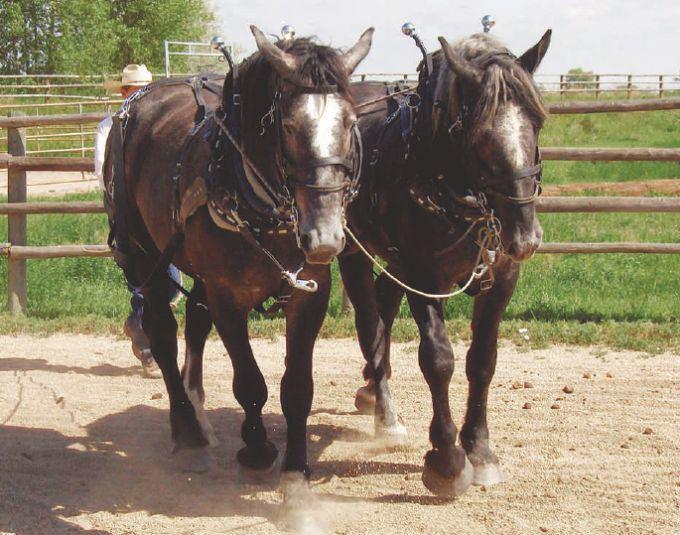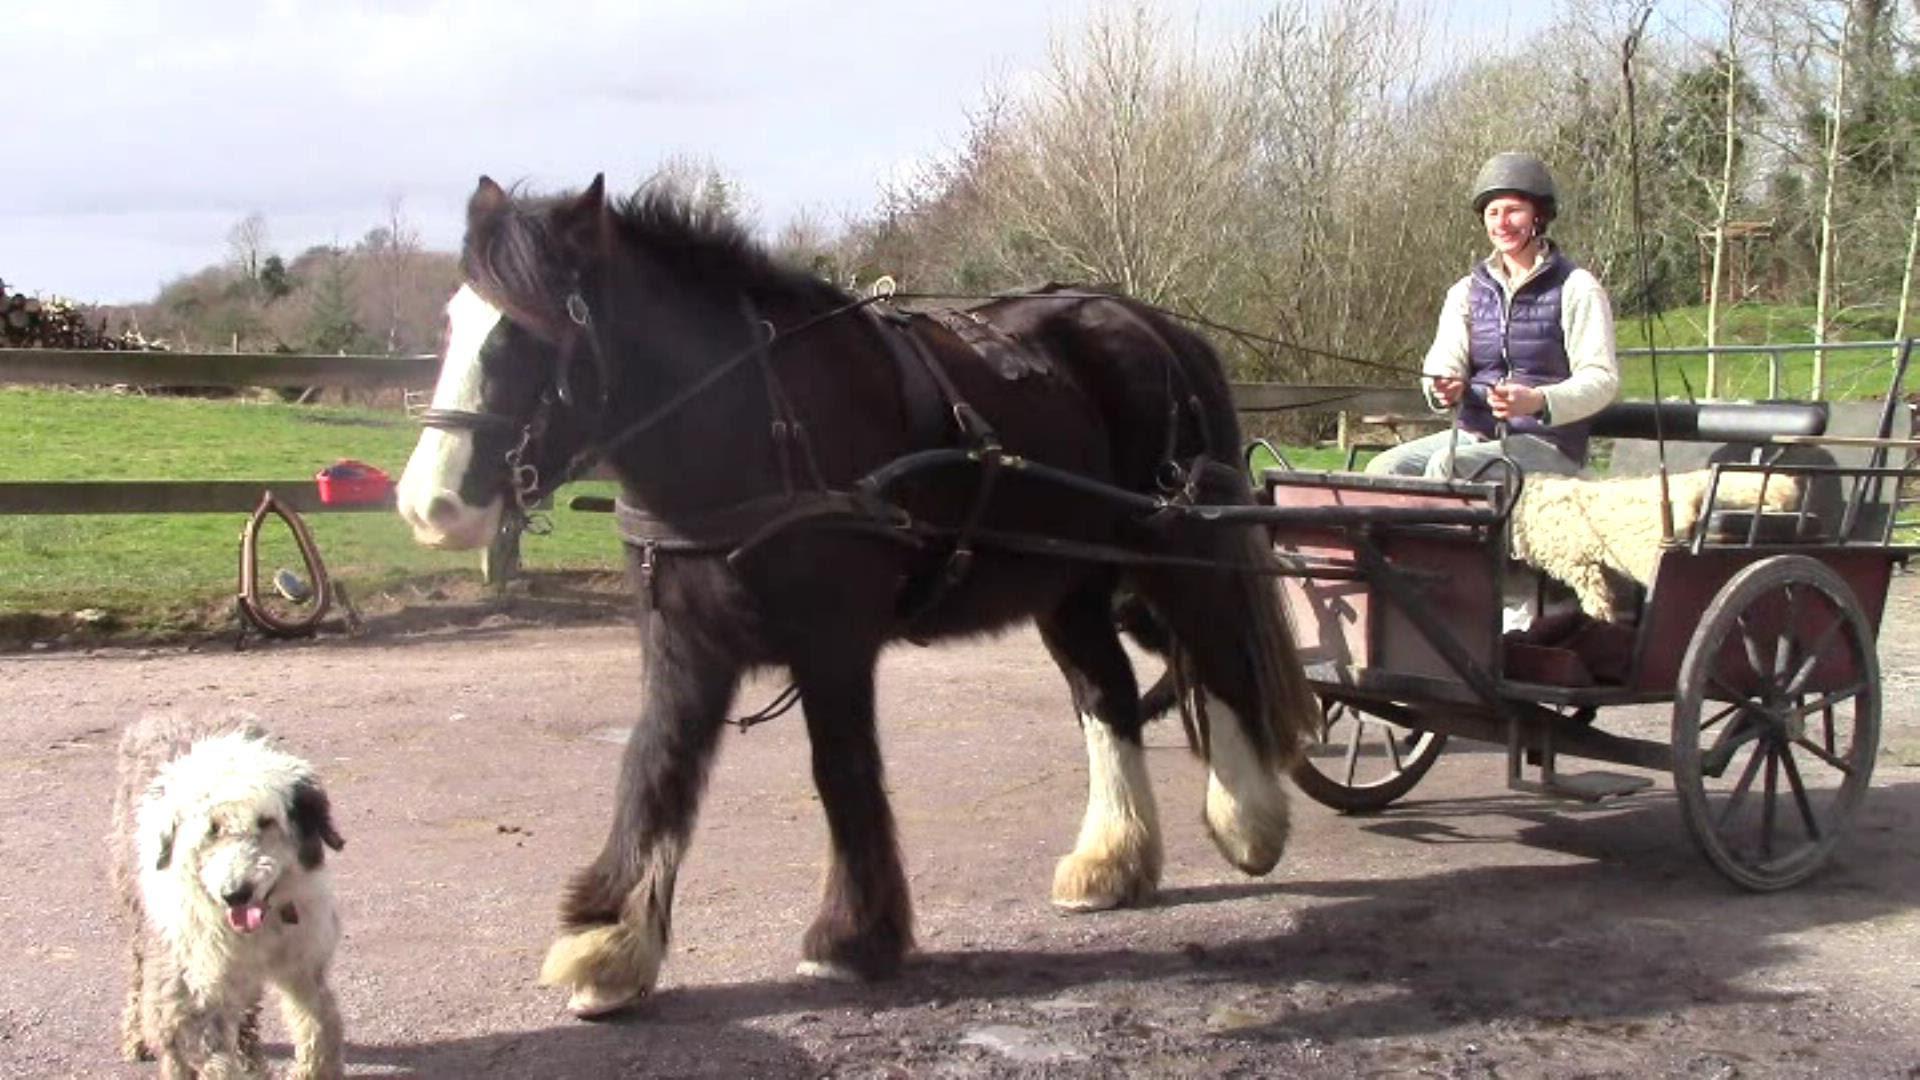The first image is the image on the left, the second image is the image on the right. Assess this claim about the two images: "there is exactly one person in the image on the right.". Correct or not? Answer yes or no. Yes. 